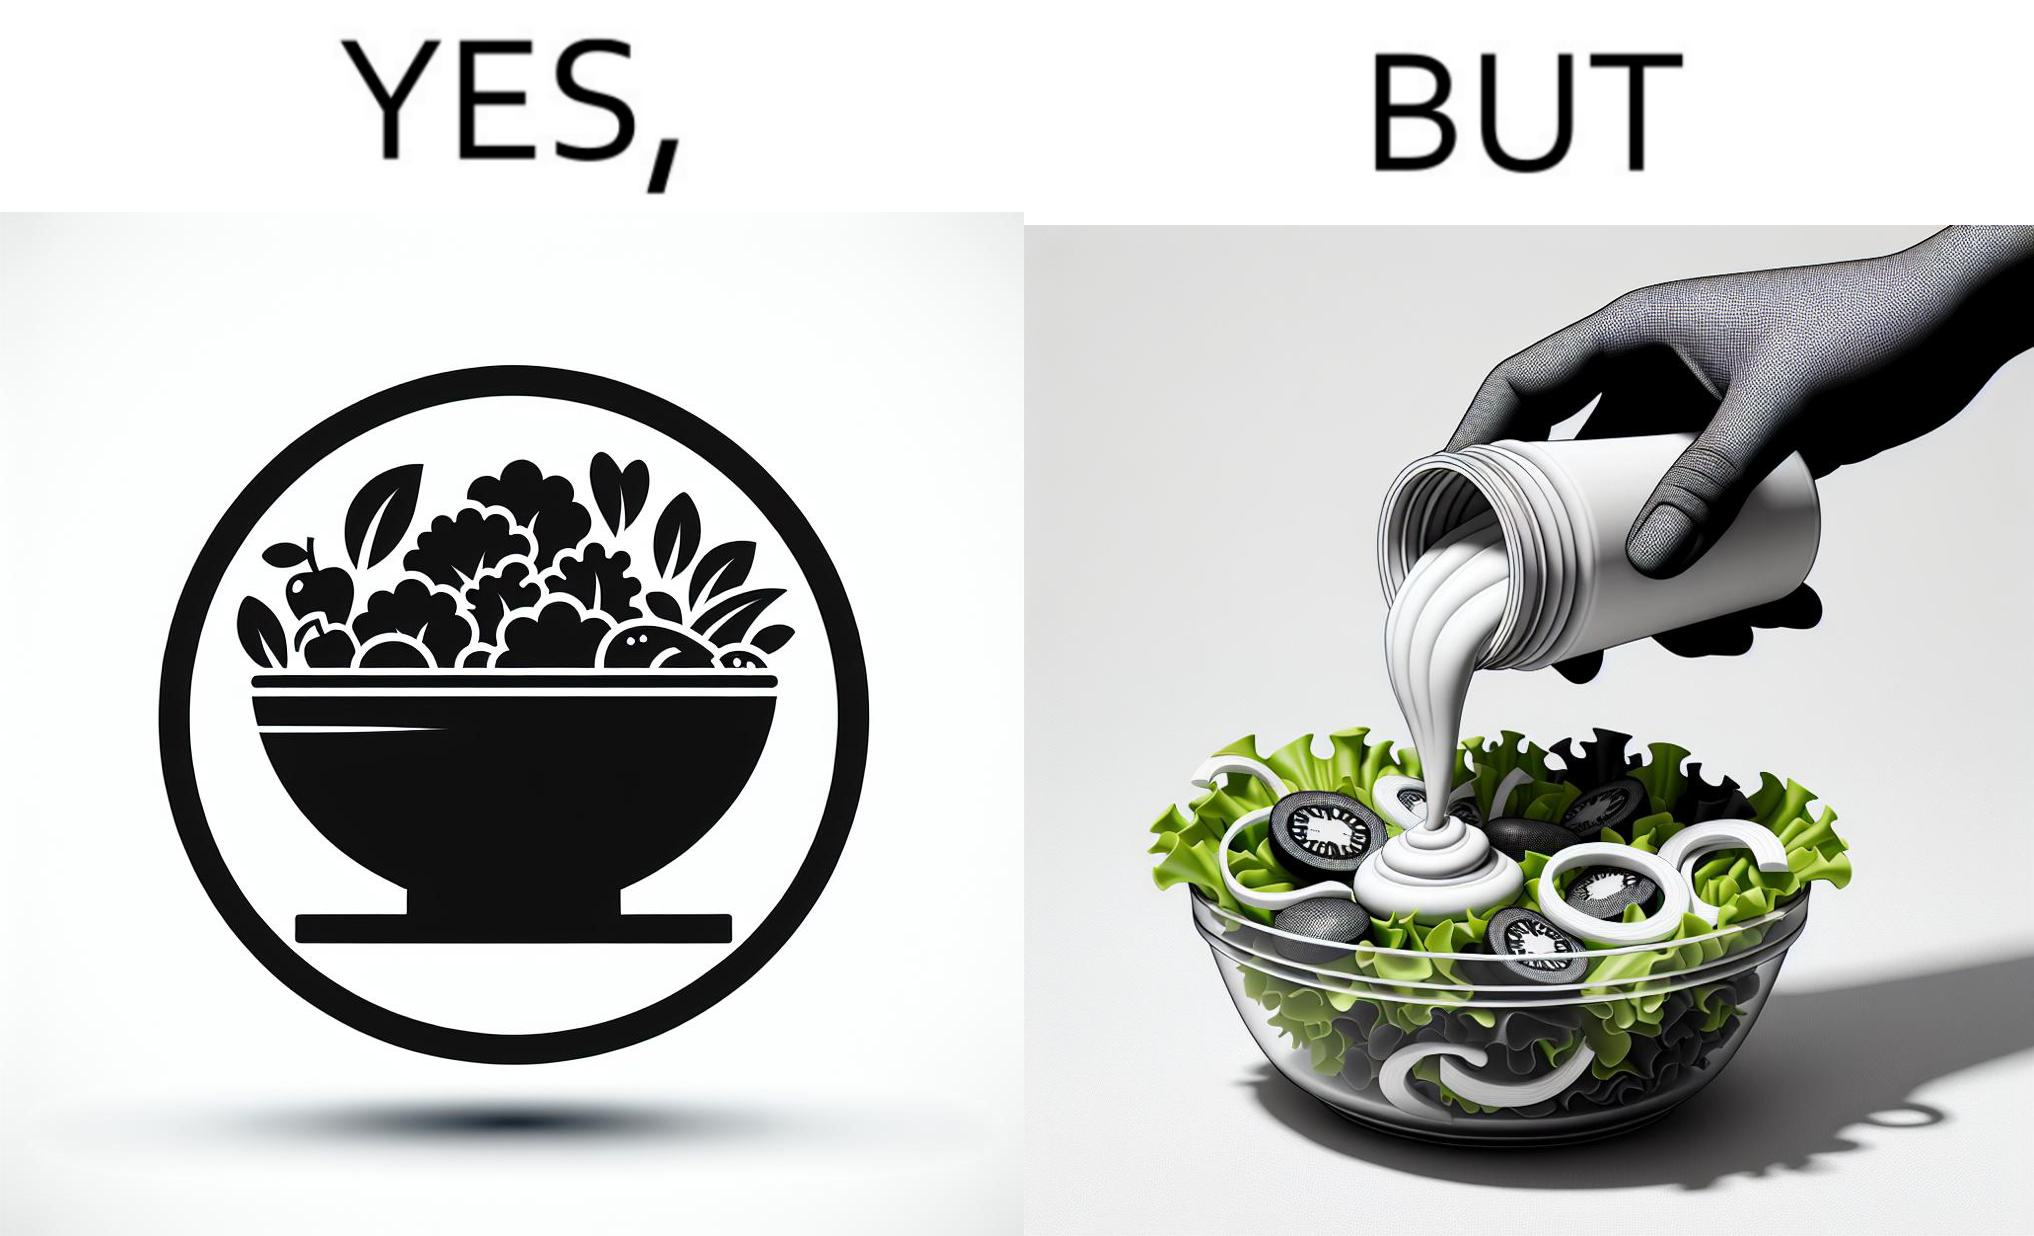What is shown in the left half versus the right half of this image? In the left part of the image: salad in a bowl In the right part of the image: pouring mayonnaise sauce on salad in a bowl 